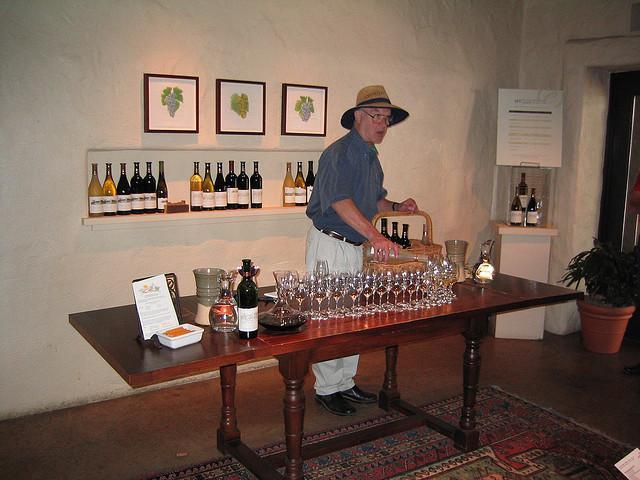How many bunches of grapes?
Give a very brief answer. 0. How many potted plants can be seen?
Give a very brief answer. 1. 